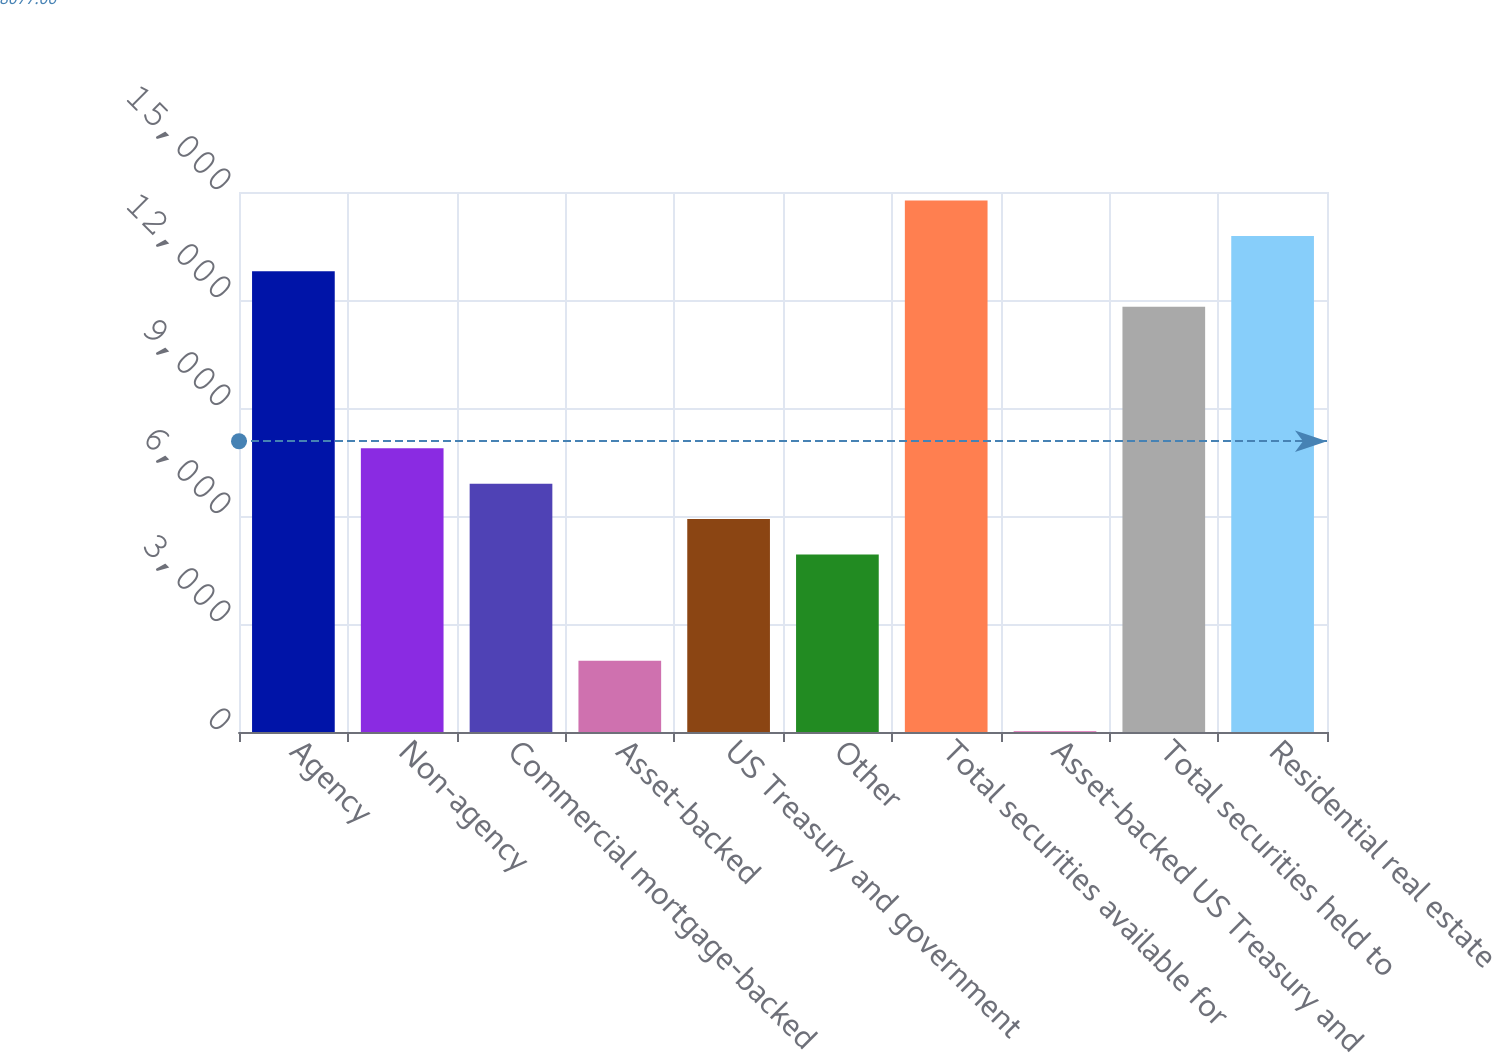<chart> <loc_0><loc_0><loc_500><loc_500><bar_chart><fcel>Agency<fcel>Non-agency<fcel>Commercial mortgage-backed<fcel>Asset-backed<fcel>US Treasury and government<fcel>Other<fcel>Total securities available for<fcel>Asset-backed US Treasury and<fcel>Total securities held to<fcel>Residential real estate<nl><fcel>12796.9<fcel>7880.4<fcel>6897.1<fcel>1980.6<fcel>5913.8<fcel>4930.5<fcel>14763.5<fcel>14<fcel>11813.6<fcel>13780.2<nl></chart> 